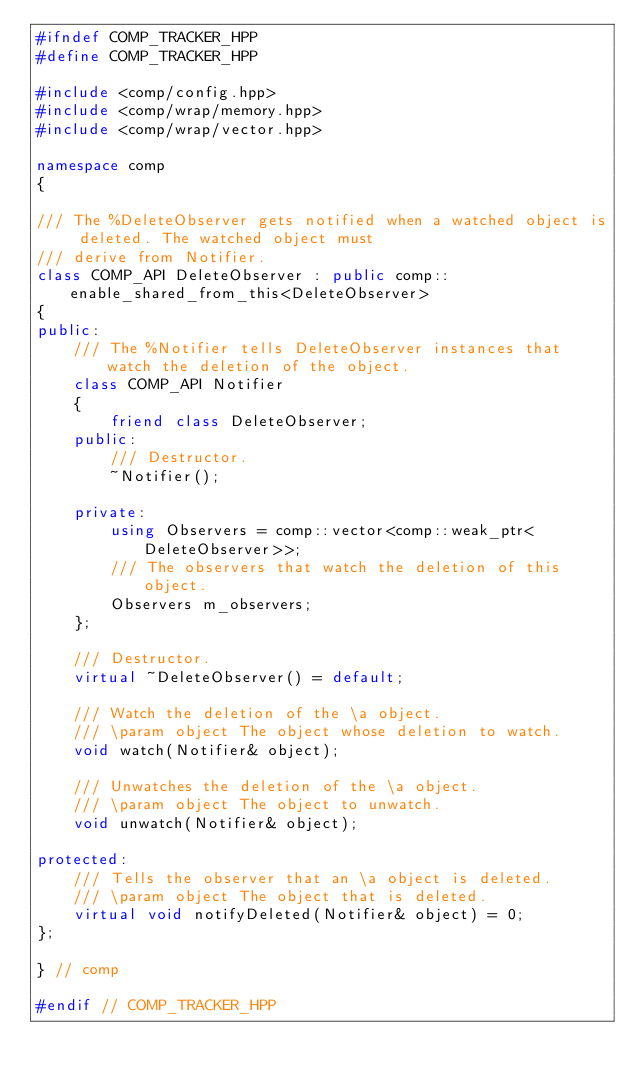Convert code to text. <code><loc_0><loc_0><loc_500><loc_500><_C++_>#ifndef COMP_TRACKER_HPP
#define COMP_TRACKER_HPP

#include <comp/config.hpp>
#include <comp/wrap/memory.hpp>
#include <comp/wrap/vector.hpp>

namespace comp
{

/// The %DeleteObserver gets notified when a watched object is deleted. The watched object must
/// derive from Notifier.
class COMP_API DeleteObserver : public comp::enable_shared_from_this<DeleteObserver>
{
public:
    /// The %Notifier tells DeleteObserver instances that watch the deletion of the object.
    class COMP_API Notifier
    {
        friend class DeleteObserver;
    public:
        /// Destructor.
        ~Notifier();

    private:
        using Observers = comp::vector<comp::weak_ptr<DeleteObserver>>;
        /// The observers that watch the deletion of this object.
        Observers m_observers;
    };

    /// Destructor.
    virtual ~DeleteObserver() = default;

    /// Watch the deletion of the \a object.
    /// \param object The object whose deletion to watch.
    void watch(Notifier& object);

    /// Unwatches the deletion of the \a object.
    /// \param object The object to unwatch.
    void unwatch(Notifier& object);

protected:
    /// Tells the observer that an \a object is deleted.
    /// \param object The object that is deleted.
    virtual void notifyDeleted(Notifier& object) = 0;
};

} // comp

#endif // COMP_TRACKER_HPP
</code> 